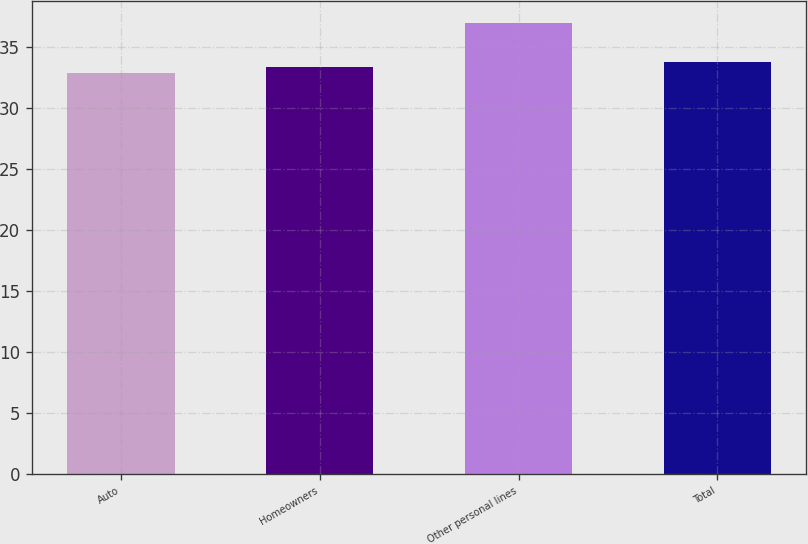<chart> <loc_0><loc_0><loc_500><loc_500><bar_chart><fcel>Auto<fcel>Homeowners<fcel>Other personal lines<fcel>Total<nl><fcel>32.8<fcel>33.3<fcel>36.9<fcel>33.71<nl></chart> 